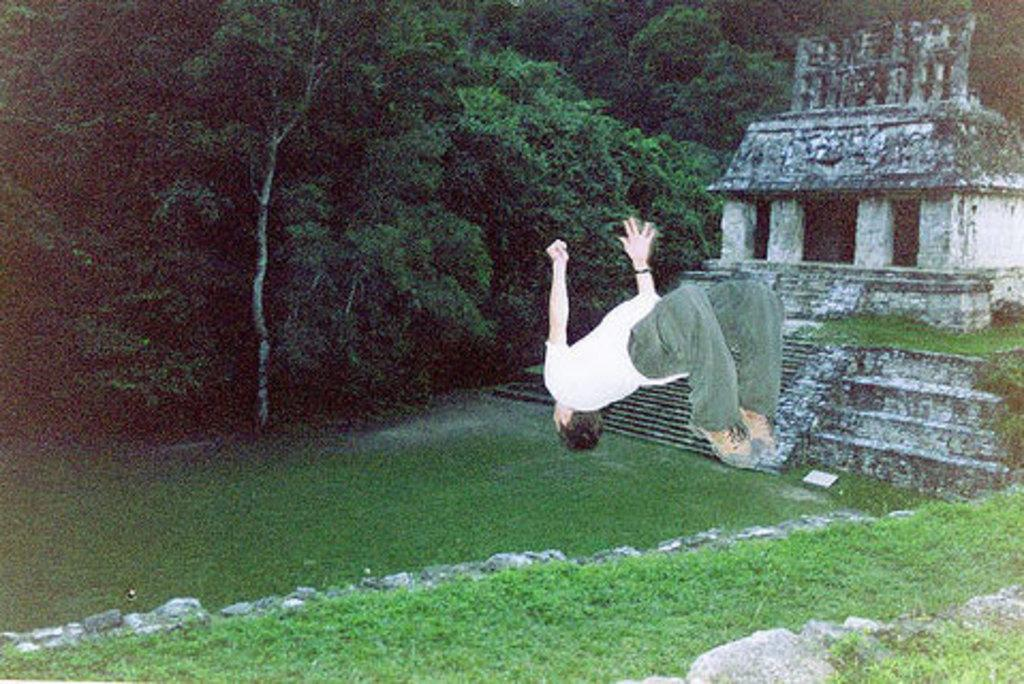Who or what is the main subject in the image? There is a person in the image. What is the person wearing? The person is wearing a white and green color dress. How is the person positioned in the image? The person appears to be in the air. What can be seen in the background of the image? There is a building and many trees in the background of the image. What type of humor can be seen in the person's facial expression in the image? There is no indication of the person's facial expression in the image, so it is not possible to determine if there is any humor present. 